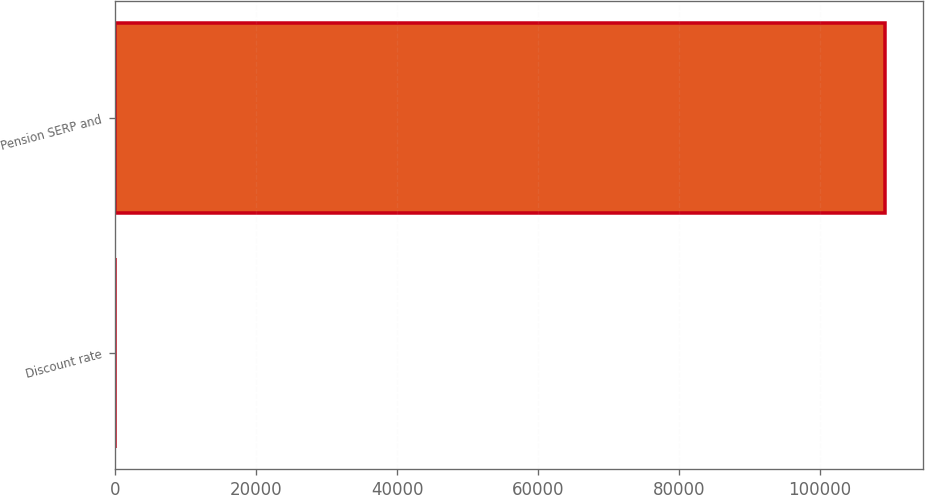Convert chart to OTSL. <chart><loc_0><loc_0><loc_500><loc_500><bar_chart><fcel>Discount rate<fcel>Pension SERP and<nl><fcel>5.49<fcel>109161<nl></chart> 